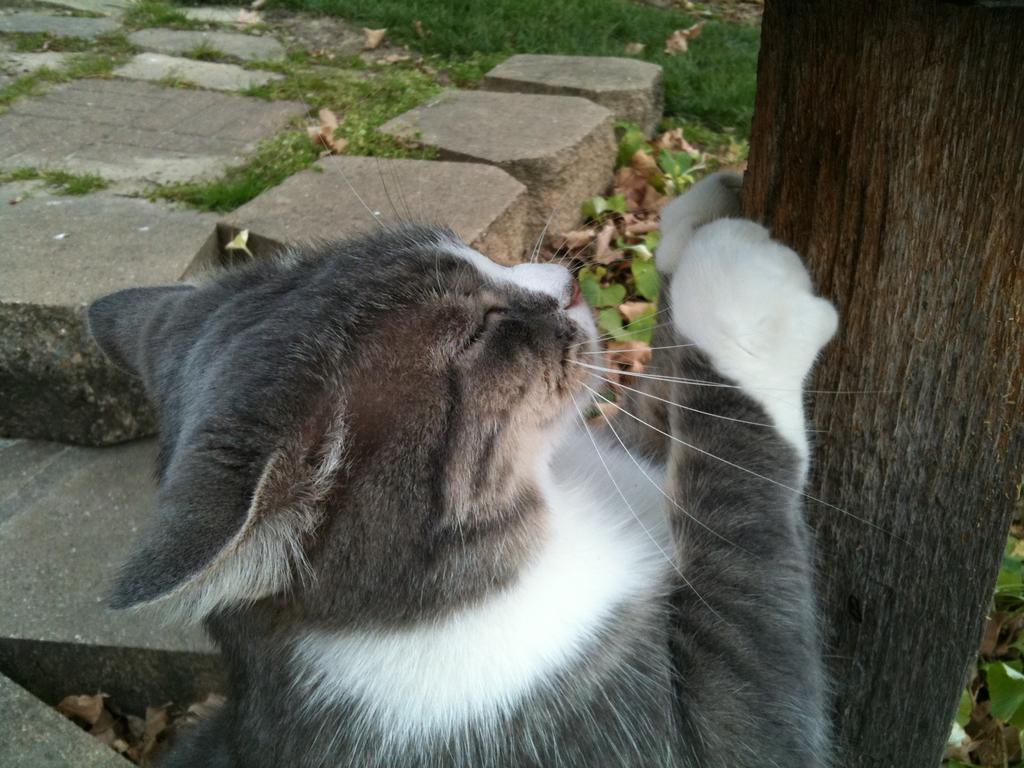Can you describe this image briefly? As we can see in the image there is a black color cat, grass and tree stem. 